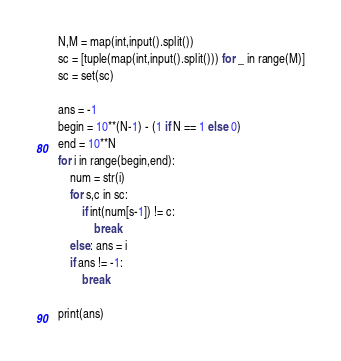<code> <loc_0><loc_0><loc_500><loc_500><_Python_>N,M = map(int,input().split())
sc = [tuple(map(int,input().split())) for _ in range(M)]
sc = set(sc)

ans = -1
begin = 10**(N-1) - (1 if N == 1 else 0)
end = 10**N
for i in range(begin,end):
    num = str(i)
    for s,c in sc:
        if int(num[s-1]) != c:
            break
    else: ans = i
    if ans != -1:
        break

print(ans)</code> 